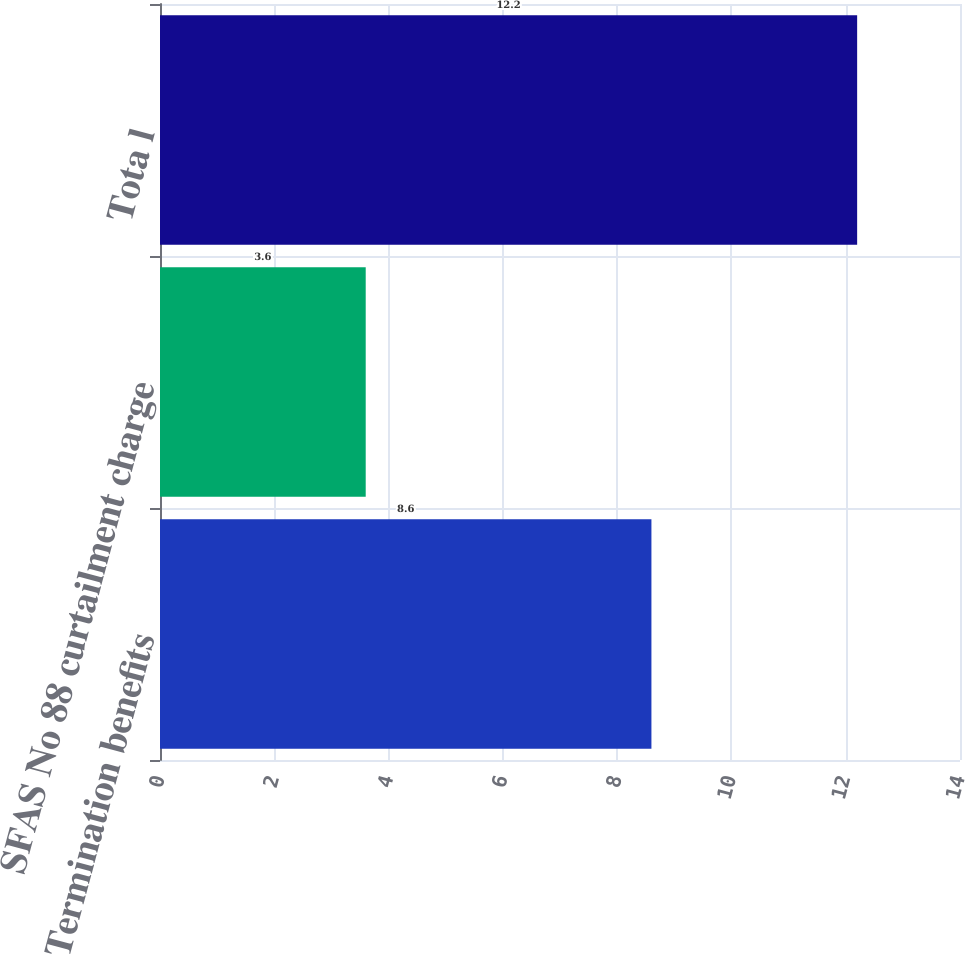Convert chart to OTSL. <chart><loc_0><loc_0><loc_500><loc_500><bar_chart><fcel>Termination benefits<fcel>SFAS No 88 curtailment charge<fcel>Tota l<nl><fcel>8.6<fcel>3.6<fcel>12.2<nl></chart> 